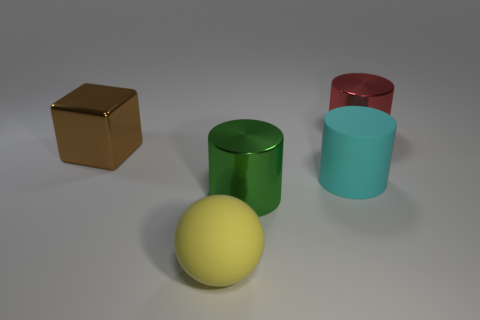How many things are red cylinders or big balls?
Your response must be concise. 2. What size is the red thing?
Provide a succinct answer. Large. There is a thing that is to the left of the cyan thing and behind the cyan rubber thing; what shape is it?
Your answer should be compact. Cube. What is the color of the other big metallic object that is the same shape as the red object?
Your response must be concise. Green. How many things are either matte objects behind the yellow sphere or cylinders that are in front of the big red cylinder?
Keep it short and to the point. 2. What is the shape of the large yellow rubber object?
Provide a short and direct response. Sphere. What number of red things have the same material as the brown cube?
Offer a terse response. 1. The large metallic block has what color?
Provide a succinct answer. Brown. There is a cube that is the same size as the cyan rubber object; what color is it?
Your answer should be compact. Brown. There is a large object that is on the right side of the big cyan thing; is it the same shape as the metal thing that is in front of the cyan thing?
Offer a terse response. Yes. 